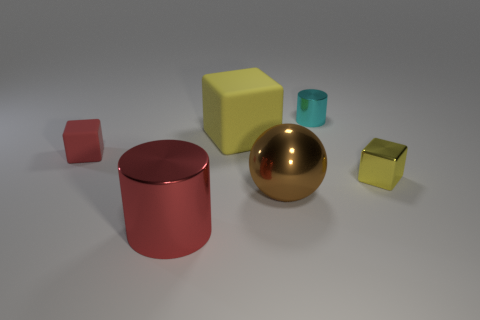Subtract all red blocks. How many blocks are left? 2 Add 3 large purple cubes. How many objects exist? 9 Subtract all yellow balls. How many yellow cubes are left? 2 Subtract all red cylinders. How many cylinders are left? 1 Subtract all red cubes. Subtract all small metal things. How many objects are left? 3 Add 4 matte objects. How many matte objects are left? 6 Add 6 big yellow things. How many big yellow things exist? 7 Subtract 0 purple cubes. How many objects are left? 6 Subtract all cylinders. How many objects are left? 4 Subtract 1 cylinders. How many cylinders are left? 1 